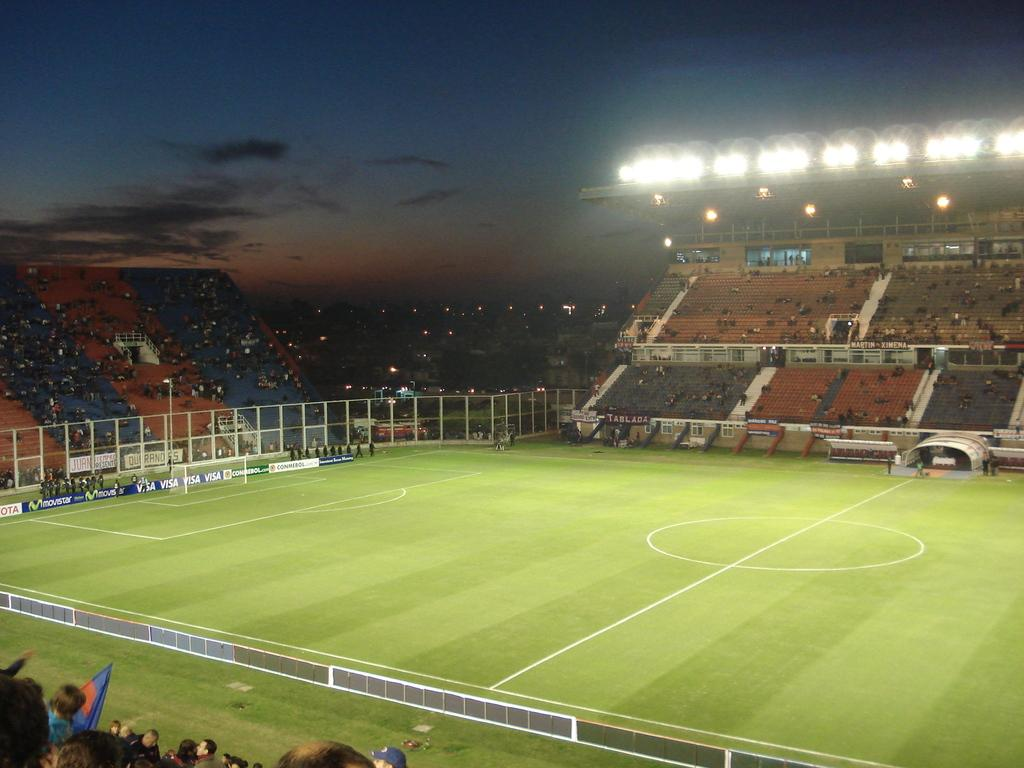Where was the image taken? The image was taken in a football stadium. What is in the middle of the stadium? There is a grass field in the middle of the stadium. What are the audience members doing in the image? The audience members are sitting around the field on chairs and watching a game. What can be seen in the sky in the image? The sky is visible in the image, and clouds are present. How many clocks can be seen hanging from the trees in the image? There are no trees or clocks present in the image; it was taken in a football stadium with a grass field and audience members watching a game. 